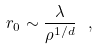Convert formula to latex. <formula><loc_0><loc_0><loc_500><loc_500>r _ { 0 } \sim \frac { \lambda } { \rho ^ { 1 / d } } \ ,</formula> 